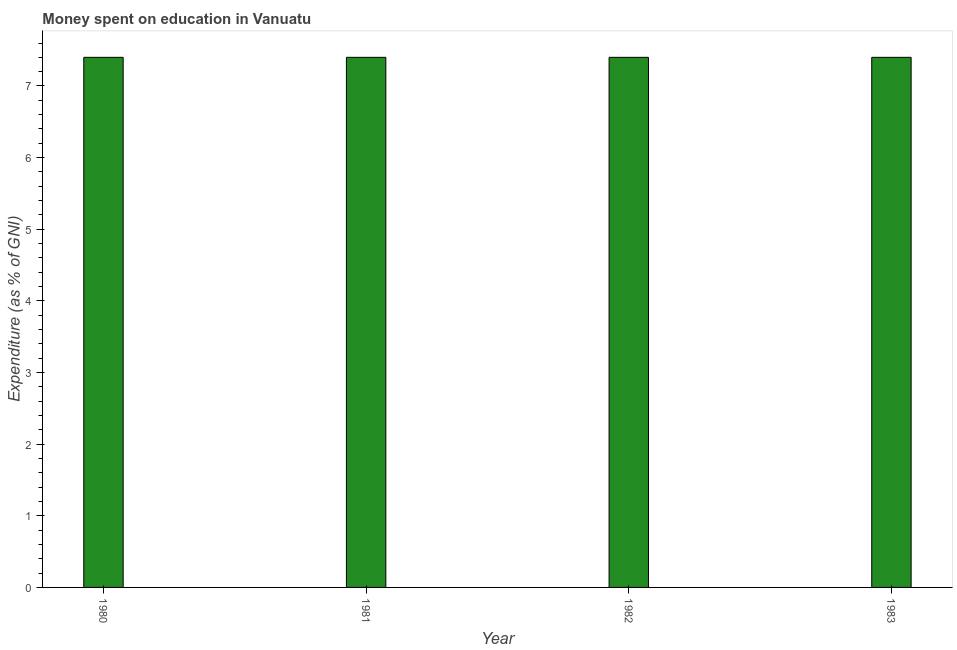Does the graph contain any zero values?
Offer a terse response. No. Does the graph contain grids?
Offer a very short reply. No. What is the title of the graph?
Give a very brief answer. Money spent on education in Vanuatu. What is the label or title of the Y-axis?
Offer a very short reply. Expenditure (as % of GNI). Across all years, what is the minimum expenditure on education?
Give a very brief answer. 7.4. In which year was the expenditure on education minimum?
Give a very brief answer. 1980. What is the sum of the expenditure on education?
Your answer should be compact. 29.6. What is the average expenditure on education per year?
Offer a terse response. 7.4. In how many years, is the expenditure on education greater than 5.4 %?
Give a very brief answer. 4. Do a majority of the years between 1982 and 1980 (inclusive) have expenditure on education greater than 1 %?
Offer a terse response. Yes. What is the ratio of the expenditure on education in 1980 to that in 1982?
Make the answer very short. 1. Is the expenditure on education in 1980 less than that in 1983?
Provide a short and direct response. No. In how many years, is the expenditure on education greater than the average expenditure on education taken over all years?
Provide a short and direct response. 0. How many bars are there?
Offer a terse response. 4. Are all the bars in the graph horizontal?
Your answer should be very brief. No. What is the Expenditure (as % of GNI) of 1981?
Provide a succinct answer. 7.4. What is the difference between the Expenditure (as % of GNI) in 1980 and 1981?
Make the answer very short. 0. What is the difference between the Expenditure (as % of GNI) in 1980 and 1982?
Provide a short and direct response. 0. What is the ratio of the Expenditure (as % of GNI) in 1980 to that in 1981?
Offer a very short reply. 1. What is the ratio of the Expenditure (as % of GNI) in 1980 to that in 1982?
Give a very brief answer. 1. What is the ratio of the Expenditure (as % of GNI) in 1980 to that in 1983?
Your answer should be very brief. 1. What is the ratio of the Expenditure (as % of GNI) in 1981 to that in 1982?
Keep it short and to the point. 1. What is the ratio of the Expenditure (as % of GNI) in 1981 to that in 1983?
Your response must be concise. 1. What is the ratio of the Expenditure (as % of GNI) in 1982 to that in 1983?
Make the answer very short. 1. 